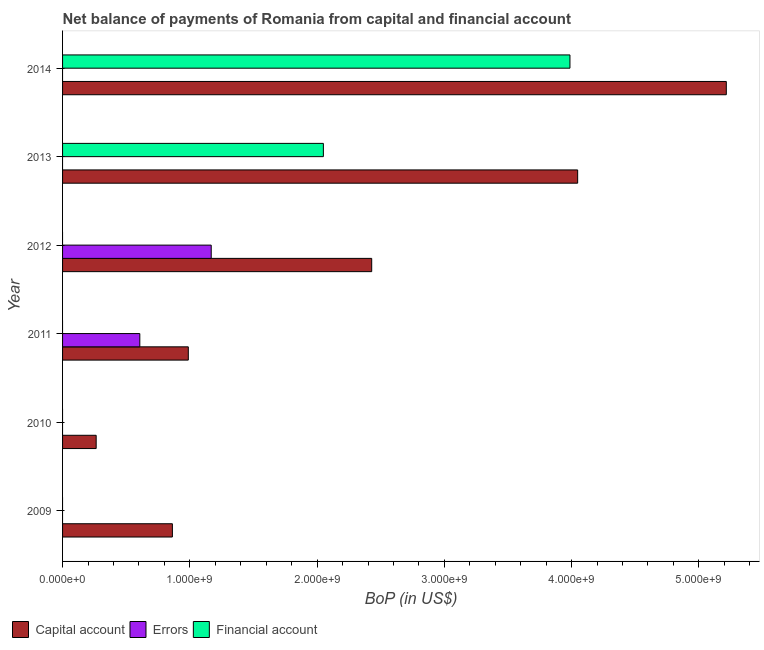How many different coloured bars are there?
Make the answer very short. 3. Are the number of bars on each tick of the Y-axis equal?
Offer a very short reply. No. How many bars are there on the 1st tick from the top?
Keep it short and to the point. 2. What is the amount of errors in 2009?
Your response must be concise. 0. Across all years, what is the maximum amount of net capital account?
Ensure brevity in your answer.  5.22e+09. Across all years, what is the minimum amount of net capital account?
Offer a terse response. 2.64e+08. What is the total amount of net capital account in the graph?
Provide a short and direct response. 1.38e+1. What is the difference between the amount of net capital account in 2013 and that in 2014?
Keep it short and to the point. -1.17e+09. What is the difference between the amount of net capital account in 2010 and the amount of financial account in 2011?
Keep it short and to the point. 2.64e+08. What is the average amount of financial account per year?
Your answer should be very brief. 1.01e+09. In the year 2014, what is the difference between the amount of net capital account and amount of financial account?
Keep it short and to the point. 1.23e+09. What is the ratio of the amount of net capital account in 2010 to that in 2014?
Offer a very short reply. 0.05. Is the amount of net capital account in 2010 less than that in 2014?
Ensure brevity in your answer.  Yes. What is the difference between the highest and the second highest amount of net capital account?
Your answer should be very brief. 1.17e+09. What is the difference between the highest and the lowest amount of net capital account?
Offer a terse response. 4.95e+09. In how many years, is the amount of financial account greater than the average amount of financial account taken over all years?
Make the answer very short. 2. Is it the case that in every year, the sum of the amount of net capital account and amount of errors is greater than the amount of financial account?
Your response must be concise. Yes. How many bars are there?
Your answer should be compact. 10. Are all the bars in the graph horizontal?
Offer a very short reply. Yes. Does the graph contain any zero values?
Make the answer very short. Yes. What is the title of the graph?
Offer a very short reply. Net balance of payments of Romania from capital and financial account. Does "Male employers" appear as one of the legend labels in the graph?
Give a very brief answer. No. What is the label or title of the X-axis?
Provide a succinct answer. BoP (in US$). What is the label or title of the Y-axis?
Your answer should be very brief. Year. What is the BoP (in US$) in Capital account in 2009?
Your answer should be very brief. 8.63e+08. What is the BoP (in US$) in Capital account in 2010?
Ensure brevity in your answer.  2.64e+08. What is the BoP (in US$) of Errors in 2010?
Offer a terse response. 0. What is the BoP (in US$) in Capital account in 2011?
Give a very brief answer. 9.88e+08. What is the BoP (in US$) in Errors in 2011?
Provide a succinct answer. 6.07e+08. What is the BoP (in US$) of Capital account in 2012?
Ensure brevity in your answer.  2.43e+09. What is the BoP (in US$) of Errors in 2012?
Make the answer very short. 1.17e+09. What is the BoP (in US$) in Capital account in 2013?
Offer a very short reply. 4.05e+09. What is the BoP (in US$) in Financial account in 2013?
Your answer should be very brief. 2.05e+09. What is the BoP (in US$) of Capital account in 2014?
Offer a terse response. 5.22e+09. What is the BoP (in US$) of Errors in 2014?
Offer a very short reply. 0. What is the BoP (in US$) in Financial account in 2014?
Provide a short and direct response. 3.99e+09. Across all years, what is the maximum BoP (in US$) of Capital account?
Offer a terse response. 5.22e+09. Across all years, what is the maximum BoP (in US$) in Errors?
Offer a very short reply. 1.17e+09. Across all years, what is the maximum BoP (in US$) in Financial account?
Provide a short and direct response. 3.99e+09. Across all years, what is the minimum BoP (in US$) of Capital account?
Your answer should be very brief. 2.64e+08. Across all years, what is the minimum BoP (in US$) of Errors?
Provide a short and direct response. 0. What is the total BoP (in US$) in Capital account in the graph?
Ensure brevity in your answer.  1.38e+1. What is the total BoP (in US$) in Errors in the graph?
Keep it short and to the point. 1.78e+09. What is the total BoP (in US$) of Financial account in the graph?
Provide a succinct answer. 6.04e+09. What is the difference between the BoP (in US$) of Capital account in 2009 and that in 2010?
Your response must be concise. 5.99e+08. What is the difference between the BoP (in US$) of Capital account in 2009 and that in 2011?
Offer a very short reply. -1.25e+08. What is the difference between the BoP (in US$) in Capital account in 2009 and that in 2012?
Your response must be concise. -1.57e+09. What is the difference between the BoP (in US$) of Capital account in 2009 and that in 2013?
Offer a terse response. -3.18e+09. What is the difference between the BoP (in US$) of Capital account in 2009 and that in 2014?
Your response must be concise. -4.35e+09. What is the difference between the BoP (in US$) of Capital account in 2010 and that in 2011?
Provide a succinct answer. -7.24e+08. What is the difference between the BoP (in US$) of Capital account in 2010 and that in 2012?
Provide a succinct answer. -2.16e+09. What is the difference between the BoP (in US$) of Capital account in 2010 and that in 2013?
Your response must be concise. -3.78e+09. What is the difference between the BoP (in US$) of Capital account in 2010 and that in 2014?
Offer a very short reply. -4.95e+09. What is the difference between the BoP (in US$) in Capital account in 2011 and that in 2012?
Keep it short and to the point. -1.44e+09. What is the difference between the BoP (in US$) in Errors in 2011 and that in 2012?
Provide a succinct answer. -5.61e+08. What is the difference between the BoP (in US$) of Capital account in 2011 and that in 2013?
Keep it short and to the point. -3.06e+09. What is the difference between the BoP (in US$) of Capital account in 2011 and that in 2014?
Your answer should be very brief. -4.23e+09. What is the difference between the BoP (in US$) of Capital account in 2012 and that in 2013?
Your answer should be very brief. -1.62e+09. What is the difference between the BoP (in US$) in Capital account in 2012 and that in 2014?
Your answer should be very brief. -2.79e+09. What is the difference between the BoP (in US$) in Capital account in 2013 and that in 2014?
Your response must be concise. -1.17e+09. What is the difference between the BoP (in US$) in Financial account in 2013 and that in 2014?
Make the answer very short. -1.94e+09. What is the difference between the BoP (in US$) in Capital account in 2009 and the BoP (in US$) in Errors in 2011?
Your answer should be compact. 2.56e+08. What is the difference between the BoP (in US$) in Capital account in 2009 and the BoP (in US$) in Errors in 2012?
Provide a succinct answer. -3.05e+08. What is the difference between the BoP (in US$) of Capital account in 2009 and the BoP (in US$) of Financial account in 2013?
Keep it short and to the point. -1.19e+09. What is the difference between the BoP (in US$) in Capital account in 2009 and the BoP (in US$) in Financial account in 2014?
Your answer should be compact. -3.12e+09. What is the difference between the BoP (in US$) in Capital account in 2010 and the BoP (in US$) in Errors in 2011?
Offer a terse response. -3.43e+08. What is the difference between the BoP (in US$) of Capital account in 2010 and the BoP (in US$) of Errors in 2012?
Keep it short and to the point. -9.04e+08. What is the difference between the BoP (in US$) in Capital account in 2010 and the BoP (in US$) in Financial account in 2013?
Make the answer very short. -1.79e+09. What is the difference between the BoP (in US$) in Capital account in 2010 and the BoP (in US$) in Financial account in 2014?
Keep it short and to the point. -3.72e+09. What is the difference between the BoP (in US$) of Capital account in 2011 and the BoP (in US$) of Errors in 2012?
Provide a short and direct response. -1.80e+08. What is the difference between the BoP (in US$) in Capital account in 2011 and the BoP (in US$) in Financial account in 2013?
Your response must be concise. -1.06e+09. What is the difference between the BoP (in US$) in Errors in 2011 and the BoP (in US$) in Financial account in 2013?
Keep it short and to the point. -1.44e+09. What is the difference between the BoP (in US$) of Capital account in 2011 and the BoP (in US$) of Financial account in 2014?
Offer a very short reply. -3.00e+09. What is the difference between the BoP (in US$) of Errors in 2011 and the BoP (in US$) of Financial account in 2014?
Provide a short and direct response. -3.38e+09. What is the difference between the BoP (in US$) of Capital account in 2012 and the BoP (in US$) of Financial account in 2013?
Provide a succinct answer. 3.80e+08. What is the difference between the BoP (in US$) of Errors in 2012 and the BoP (in US$) of Financial account in 2013?
Keep it short and to the point. -8.81e+08. What is the difference between the BoP (in US$) of Capital account in 2012 and the BoP (in US$) of Financial account in 2014?
Give a very brief answer. -1.56e+09. What is the difference between the BoP (in US$) in Errors in 2012 and the BoP (in US$) in Financial account in 2014?
Give a very brief answer. -2.82e+09. What is the difference between the BoP (in US$) of Capital account in 2013 and the BoP (in US$) of Financial account in 2014?
Your answer should be compact. 6.05e+07. What is the average BoP (in US$) in Capital account per year?
Your response must be concise. 2.30e+09. What is the average BoP (in US$) of Errors per year?
Your answer should be very brief. 2.96e+08. What is the average BoP (in US$) of Financial account per year?
Your answer should be very brief. 1.01e+09. In the year 2011, what is the difference between the BoP (in US$) in Capital account and BoP (in US$) in Errors?
Your answer should be compact. 3.81e+08. In the year 2012, what is the difference between the BoP (in US$) of Capital account and BoP (in US$) of Errors?
Your answer should be compact. 1.26e+09. In the year 2013, what is the difference between the BoP (in US$) of Capital account and BoP (in US$) of Financial account?
Make the answer very short. 2.00e+09. In the year 2014, what is the difference between the BoP (in US$) in Capital account and BoP (in US$) in Financial account?
Keep it short and to the point. 1.23e+09. What is the ratio of the BoP (in US$) of Capital account in 2009 to that in 2010?
Provide a succinct answer. 3.27. What is the ratio of the BoP (in US$) in Capital account in 2009 to that in 2011?
Your answer should be compact. 0.87. What is the ratio of the BoP (in US$) of Capital account in 2009 to that in 2012?
Your answer should be compact. 0.36. What is the ratio of the BoP (in US$) in Capital account in 2009 to that in 2013?
Provide a succinct answer. 0.21. What is the ratio of the BoP (in US$) in Capital account in 2009 to that in 2014?
Make the answer very short. 0.17. What is the ratio of the BoP (in US$) of Capital account in 2010 to that in 2011?
Make the answer very short. 0.27. What is the ratio of the BoP (in US$) in Capital account in 2010 to that in 2012?
Your answer should be very brief. 0.11. What is the ratio of the BoP (in US$) of Capital account in 2010 to that in 2013?
Provide a succinct answer. 0.07. What is the ratio of the BoP (in US$) of Capital account in 2010 to that in 2014?
Ensure brevity in your answer.  0.05. What is the ratio of the BoP (in US$) in Capital account in 2011 to that in 2012?
Offer a terse response. 0.41. What is the ratio of the BoP (in US$) in Errors in 2011 to that in 2012?
Provide a succinct answer. 0.52. What is the ratio of the BoP (in US$) in Capital account in 2011 to that in 2013?
Provide a succinct answer. 0.24. What is the ratio of the BoP (in US$) of Capital account in 2011 to that in 2014?
Offer a very short reply. 0.19. What is the ratio of the BoP (in US$) of Capital account in 2012 to that in 2013?
Ensure brevity in your answer.  0.6. What is the ratio of the BoP (in US$) of Capital account in 2012 to that in 2014?
Offer a very short reply. 0.47. What is the ratio of the BoP (in US$) of Capital account in 2013 to that in 2014?
Your answer should be very brief. 0.78. What is the ratio of the BoP (in US$) in Financial account in 2013 to that in 2014?
Your answer should be very brief. 0.51. What is the difference between the highest and the second highest BoP (in US$) of Capital account?
Keep it short and to the point. 1.17e+09. What is the difference between the highest and the lowest BoP (in US$) of Capital account?
Make the answer very short. 4.95e+09. What is the difference between the highest and the lowest BoP (in US$) of Errors?
Your response must be concise. 1.17e+09. What is the difference between the highest and the lowest BoP (in US$) of Financial account?
Offer a very short reply. 3.99e+09. 